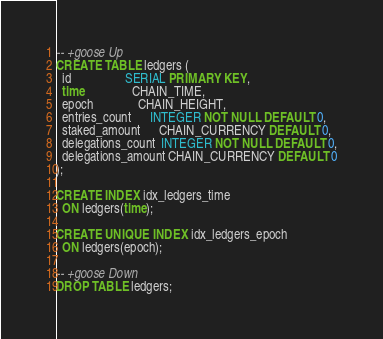<code> <loc_0><loc_0><loc_500><loc_500><_SQL_>-- +goose Up
CREATE TABLE ledgers (
  id                 SERIAL PRIMARY KEY,
  time               CHAIN_TIME,
  epoch              CHAIN_HEIGHT,
  entries_count      INTEGER NOT NULL DEFAULT 0,
  staked_amount      CHAIN_CURRENCY DEFAULT 0,
  delegations_count  INTEGER NOT NULL DEFAULT 0,
  delegations_amount CHAIN_CURRENCY DEFAULT 0
);

CREATE INDEX idx_ledgers_time
  ON ledgers(time);

CREATE UNIQUE INDEX idx_ledgers_epoch
  ON ledgers(epoch);

-- +goose Down
DROP TABLE ledgers;
</code> 